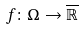Convert formula to latex. <formula><loc_0><loc_0><loc_500><loc_500>f \colon \Omega \rightarrow \overline { \mathbb { R } }</formula> 